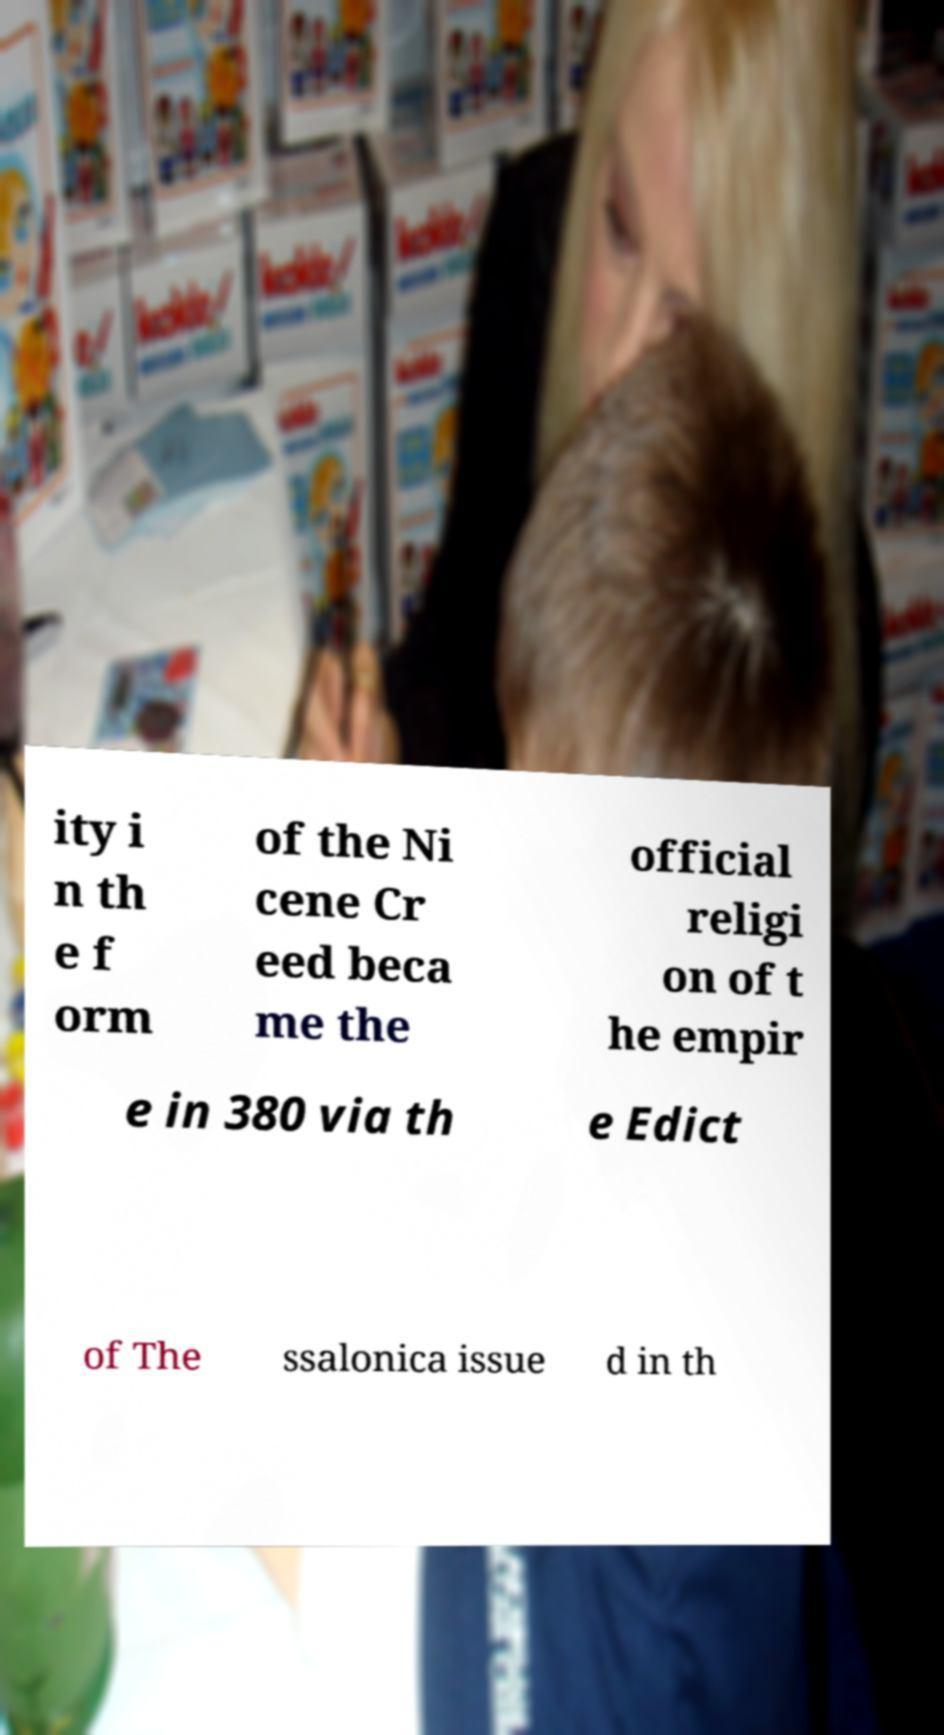Please identify and transcribe the text found in this image. ity i n th e f orm of the Ni cene Cr eed beca me the official religi on of t he empir e in 380 via th e Edict of The ssalonica issue d in th 